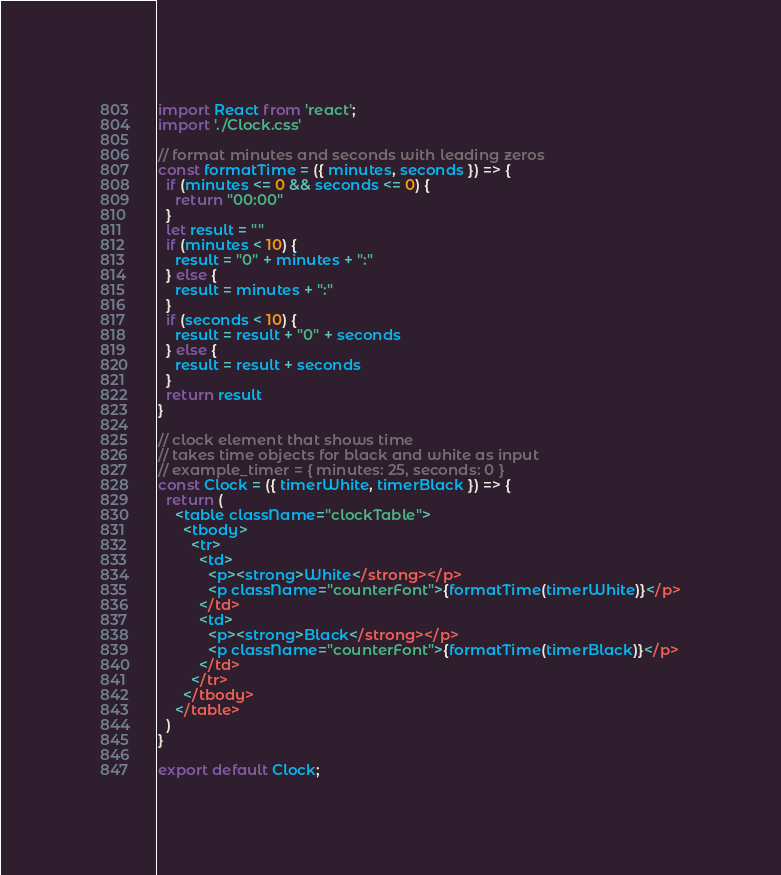Convert code to text. <code><loc_0><loc_0><loc_500><loc_500><_JavaScript_>import React from 'react';
import './Clock.css'

// format minutes and seconds with leading zeros
const formatTime = ({ minutes, seconds }) => {
  if (minutes <= 0 && seconds <= 0) {
    return "00:00"
  }
  let result = ""
  if (minutes < 10) {
    result = "0" + minutes + ":"
  } else {
    result = minutes + ":"
  }
  if (seconds < 10) {
    result = result + "0" + seconds
  } else {
    result = result + seconds
  }
  return result
}

// clock element that shows time
// takes time objects for black and white as input
// example_timer = { minutes: 25, seconds: 0 }
const Clock = ({ timerWhite, timerBlack }) => {
  return (
    <table className="clockTable">
      <tbody>
        <tr>
          <td>
            <p><strong>White</strong></p>
            <p className="counterFont">{formatTime(timerWhite)}</p>
          </td>
          <td>
            <p><strong>Black</strong></p>
            <p className="counterFont">{formatTime(timerBlack)}</p>
          </td>
        </tr>
      </tbody>
    </table>
  )
}

export default Clock;</code> 